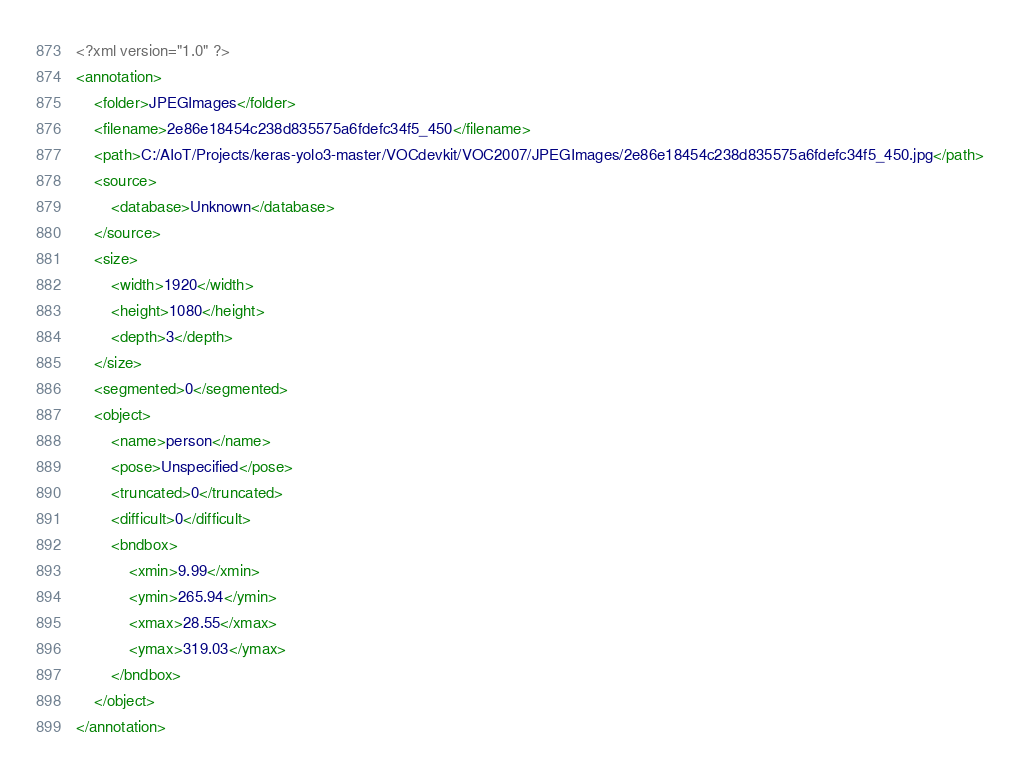<code> <loc_0><loc_0><loc_500><loc_500><_XML_><?xml version="1.0" ?>
<annotation>
	<folder>JPEGImages</folder>
	<filename>2e86e18454c238d835575a6fdefc34f5_450</filename>
	<path>C:/AIoT/Projects/keras-yolo3-master/VOCdevkit/VOC2007/JPEGImages/2e86e18454c238d835575a6fdefc34f5_450.jpg</path>
	<source>
		<database>Unknown</database>
	</source>
	<size>
		<width>1920</width>
		<height>1080</height>
		<depth>3</depth>
	</size>
	<segmented>0</segmented>
	<object>
		<name>person</name>
		<pose>Unspecified</pose>
		<truncated>0</truncated>
		<difficult>0</difficult>
		<bndbox>
			<xmin>9.99</xmin>
			<ymin>265.94</ymin>
			<xmax>28.55</xmax>
			<ymax>319.03</ymax>
		</bndbox>
	</object>
</annotation>
</code> 